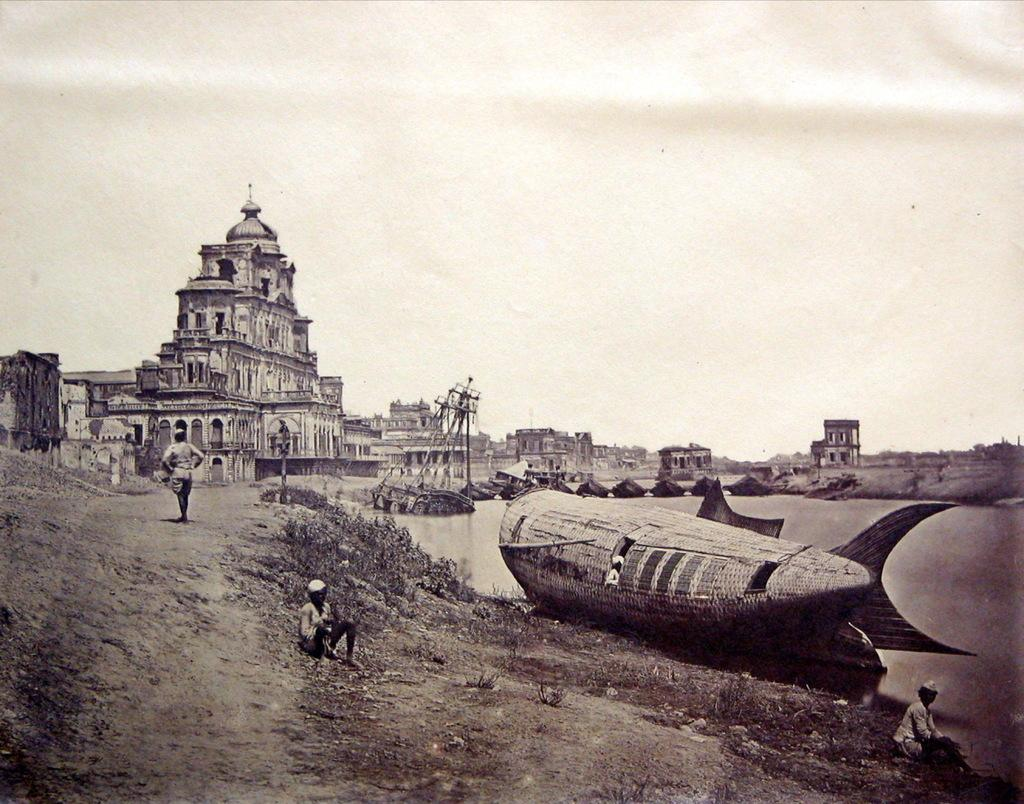What is the color scheme of the image? The image is black and white. What can be seen floating on the water in the image? There are boats in the image. What is the water in the image situated on? The water is visible in the image. Who or what is present in the image? There are people in the image. What type of structures can be seen in the image? There are buildings in the image. What else is visible in the image besides the water and boats? The sky is visible in the image. Can you describe any other objects in the image? There are objects in the image. Where is the rake being used in the image? There is no rake present in the image. What type of waste can be seen in the field in the image? There is no field or waste present in the image. 